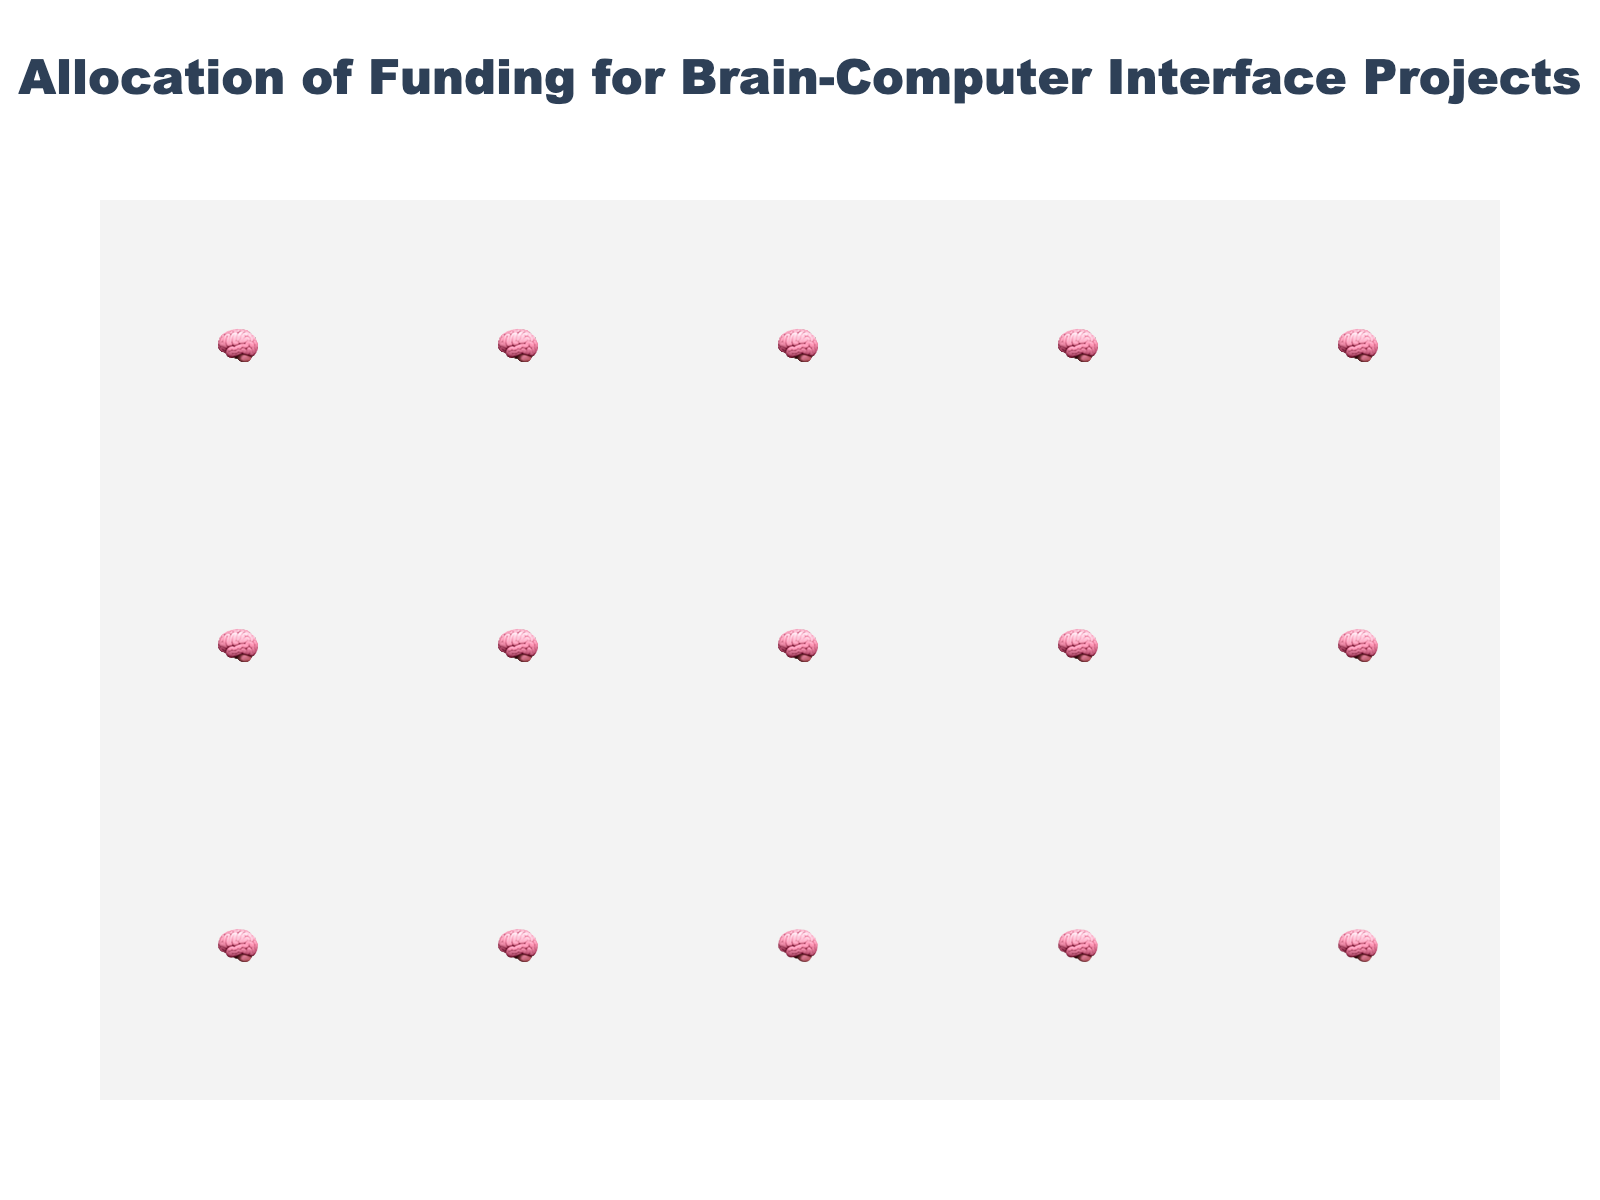Which application area received the most funding? Look at the application with the highest number of pictograms. Medical Rehabilitation has the most pictograms, indicating the highest funding.
Answer: Medical Rehabilitation What is the total funding allocated to Gaming and Entertainment and Military Applications combined? Sum the funding amounts for Gaming and Entertainment (50M USD) and Military Applications (40M USD): 50 + 40 = 90M USD.
Answer: 90M USD How many pictograms are used for Neuroprosthetics? Count the pictograms representing Neuroprosthetics, which is indicated by the count value in the data.
Answer: 7 Which application received less funding than Neurofeedback Therapy but more than Neuromarketing? Compare the funding amounts of the applications. Cognitive Enhancement (80M USD) fits this criterion as it is less than Neurofeedback Therapy (90M USD) and more than Neuromarketing (30M USD).
Answer: Cognitive Enhancement What is the average funding for Brain-Computer Communication and Cognitive Enhancement? Calculate the average by summing the values (120M USD + 80M USD) and dividing by 2: (120 + 80) / 2 = 100M USD.
Answer: 100M USD Which application has the third highest amount of funding? Arrange the applications by their funding amounts and select the one with the third highest funding. Neurofeedback Therapy (90M USD) is third after Medical Rehabilitation (150M USD) and Brain-Computer Communication (120M USD).
Answer: Neurofeedback Therapy How does the funding for Medical Rehabilitation compare to Gaming and Entertainment? Compare the funding values for Medical Rehabilitation (150M USD) and Gaming and Entertainment (50M USD). Medical Rehabilitation has substantially more funding.
Answer: Medical Rehabilitation has significantly more funding If the funding for Neuroprosthetics was doubled, what would be the new total funding in that category? Double the current funding of Neuroprosthetics (70M USD): 70 * 2 = 140M USD.
Answer: 140M USD What is the total count of all pictograms in the plot? Sum the pictogram counts for all application areas: 15 + 12 + 9 + 8 + 7 + 5 + 4 + 3 = 63.
Answer: 63 Which application area has half the funding amount of Cognitive Enhancement? Identify the application with funding that is half of Cognitive Enhancement's (80M USD / 2 = 40M USD). Military Applications fits this criterion with funding exactly 40M USD.
Answer: Military Applications 